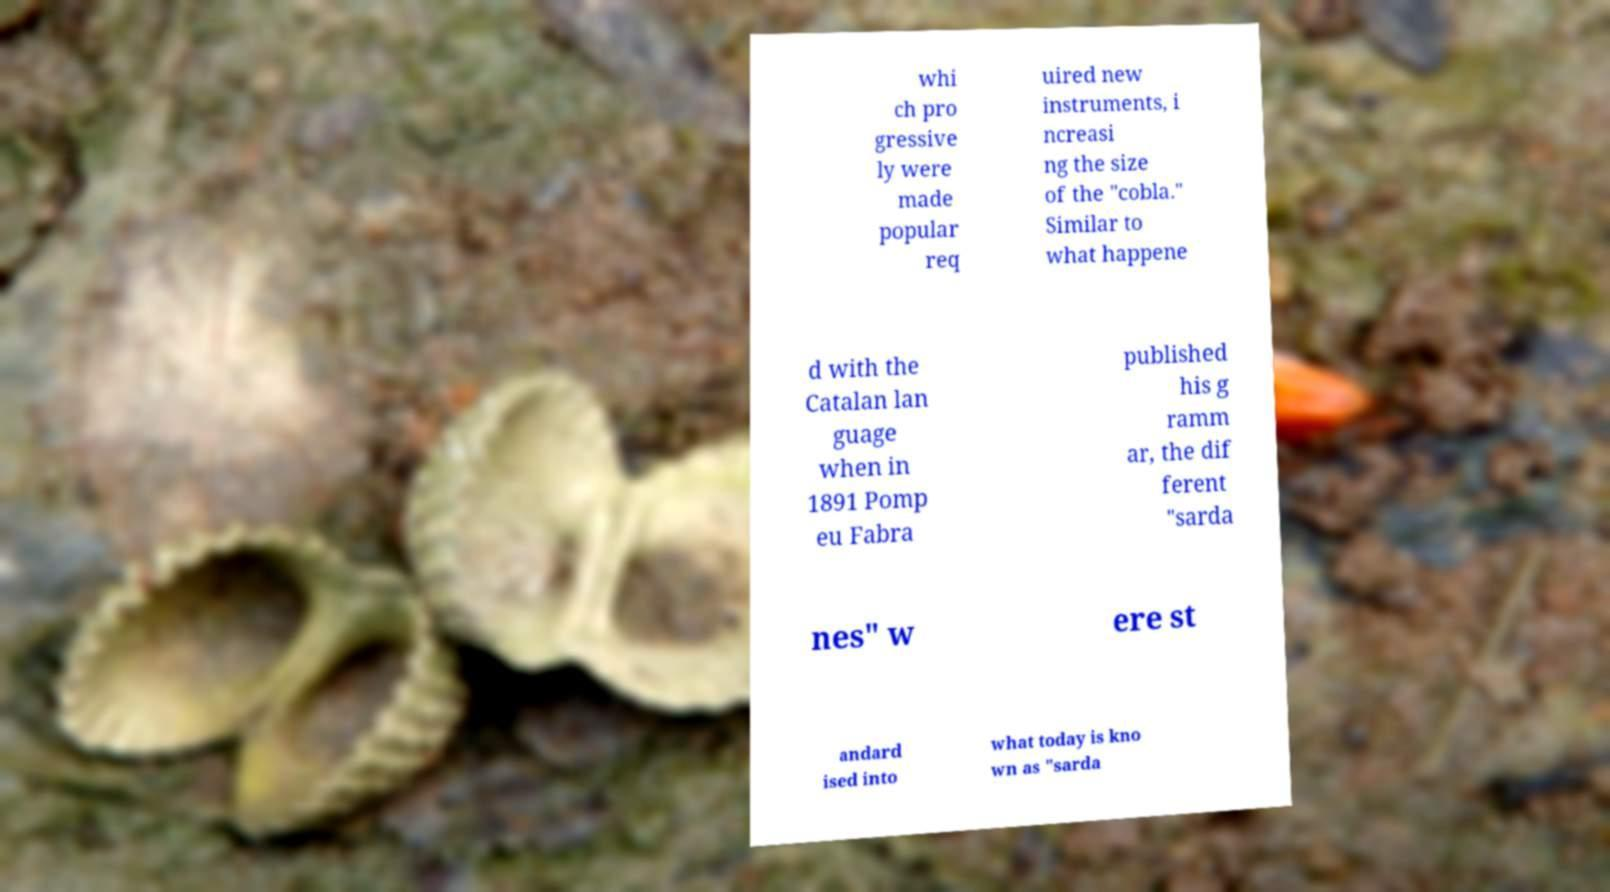Could you extract and type out the text from this image? whi ch pro gressive ly were made popular req uired new instruments, i ncreasi ng the size of the "cobla." Similar to what happene d with the Catalan lan guage when in 1891 Pomp eu Fabra published his g ramm ar, the dif ferent "sarda nes" w ere st andard ised into what today is kno wn as "sarda 